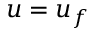<formula> <loc_0><loc_0><loc_500><loc_500>u = u _ { f }</formula> 